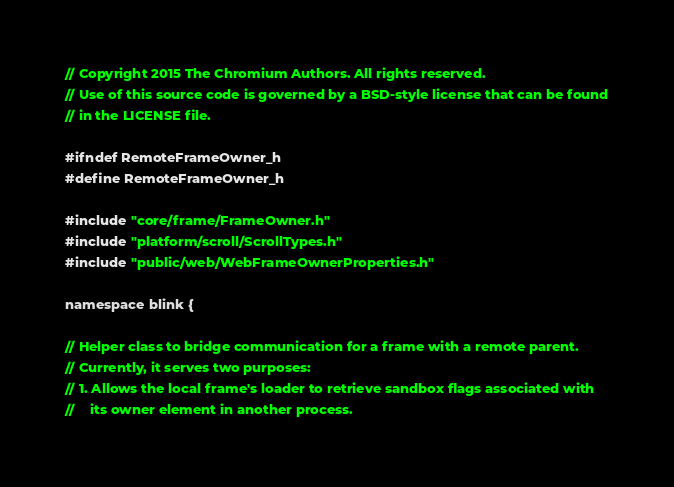Convert code to text. <code><loc_0><loc_0><loc_500><loc_500><_C_>// Copyright 2015 The Chromium Authors. All rights reserved.
// Use of this source code is governed by a BSD-style license that can be found
// in the LICENSE file.

#ifndef RemoteFrameOwner_h
#define RemoteFrameOwner_h

#include "core/frame/FrameOwner.h"
#include "platform/scroll/ScrollTypes.h"
#include "public/web/WebFrameOwnerProperties.h"

namespace blink {

// Helper class to bridge communication for a frame with a remote parent.
// Currently, it serves two purposes:
// 1. Allows the local frame's loader to retrieve sandbox flags associated with
//    its owner element in another process.</code> 